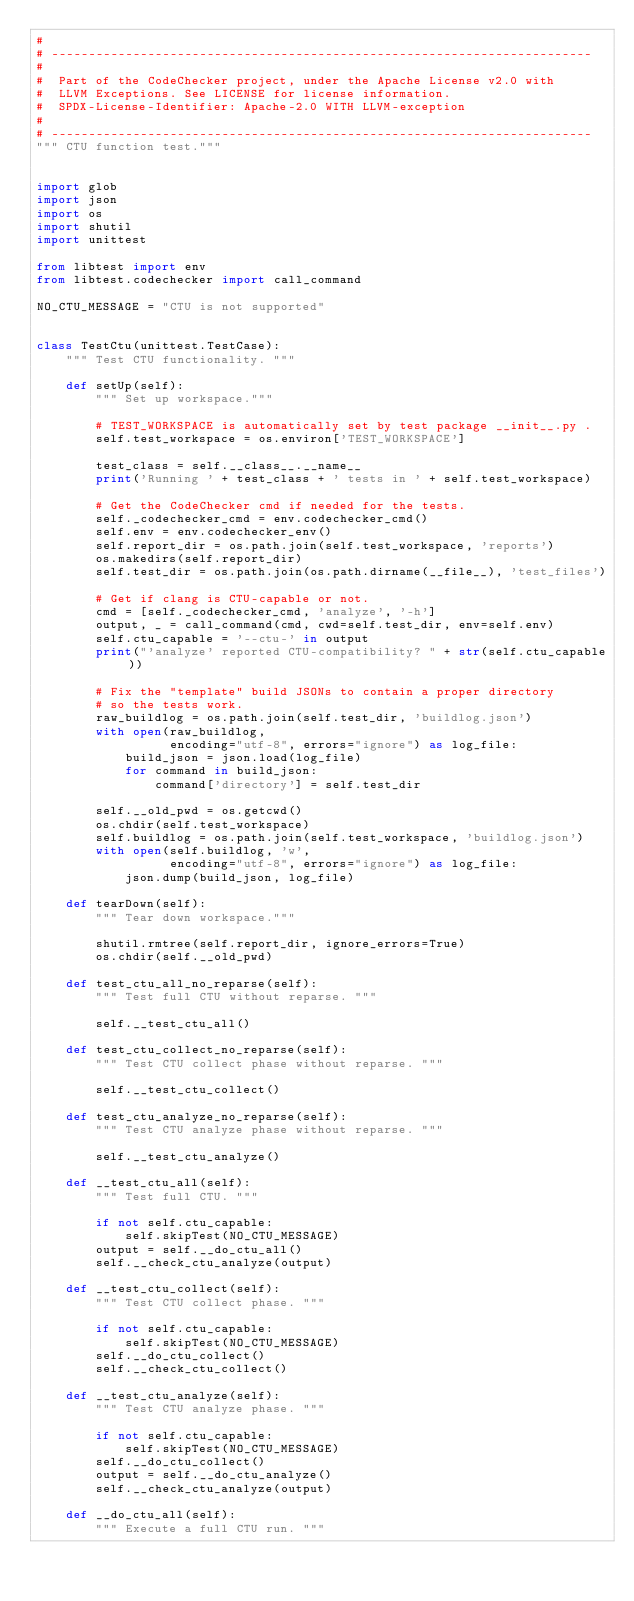Convert code to text. <code><loc_0><loc_0><loc_500><loc_500><_Python_>#
# -------------------------------------------------------------------------
#
#  Part of the CodeChecker project, under the Apache License v2.0 with
#  LLVM Exceptions. See LICENSE for license information.
#  SPDX-License-Identifier: Apache-2.0 WITH LLVM-exception
#
# -------------------------------------------------------------------------
""" CTU function test."""


import glob
import json
import os
import shutil
import unittest

from libtest import env
from libtest.codechecker import call_command

NO_CTU_MESSAGE = "CTU is not supported"


class TestCtu(unittest.TestCase):
    """ Test CTU functionality. """

    def setUp(self):
        """ Set up workspace."""

        # TEST_WORKSPACE is automatically set by test package __init__.py .
        self.test_workspace = os.environ['TEST_WORKSPACE']

        test_class = self.__class__.__name__
        print('Running ' + test_class + ' tests in ' + self.test_workspace)

        # Get the CodeChecker cmd if needed for the tests.
        self._codechecker_cmd = env.codechecker_cmd()
        self.env = env.codechecker_env()
        self.report_dir = os.path.join(self.test_workspace, 'reports')
        os.makedirs(self.report_dir)
        self.test_dir = os.path.join(os.path.dirname(__file__), 'test_files')

        # Get if clang is CTU-capable or not.
        cmd = [self._codechecker_cmd, 'analyze', '-h']
        output, _ = call_command(cmd, cwd=self.test_dir, env=self.env)
        self.ctu_capable = '--ctu-' in output
        print("'analyze' reported CTU-compatibility? " + str(self.ctu_capable))

        # Fix the "template" build JSONs to contain a proper directory
        # so the tests work.
        raw_buildlog = os.path.join(self.test_dir, 'buildlog.json')
        with open(raw_buildlog,
                  encoding="utf-8", errors="ignore") as log_file:
            build_json = json.load(log_file)
            for command in build_json:
                command['directory'] = self.test_dir

        self.__old_pwd = os.getcwd()
        os.chdir(self.test_workspace)
        self.buildlog = os.path.join(self.test_workspace, 'buildlog.json')
        with open(self.buildlog, 'w',
                  encoding="utf-8", errors="ignore") as log_file:
            json.dump(build_json, log_file)

    def tearDown(self):
        """ Tear down workspace."""

        shutil.rmtree(self.report_dir, ignore_errors=True)
        os.chdir(self.__old_pwd)

    def test_ctu_all_no_reparse(self):
        """ Test full CTU without reparse. """

        self.__test_ctu_all()

    def test_ctu_collect_no_reparse(self):
        """ Test CTU collect phase without reparse. """

        self.__test_ctu_collect()

    def test_ctu_analyze_no_reparse(self):
        """ Test CTU analyze phase without reparse. """

        self.__test_ctu_analyze()

    def __test_ctu_all(self):
        """ Test full CTU. """

        if not self.ctu_capable:
            self.skipTest(NO_CTU_MESSAGE)
        output = self.__do_ctu_all()
        self.__check_ctu_analyze(output)

    def __test_ctu_collect(self):
        """ Test CTU collect phase. """

        if not self.ctu_capable:
            self.skipTest(NO_CTU_MESSAGE)
        self.__do_ctu_collect()
        self.__check_ctu_collect()

    def __test_ctu_analyze(self):
        """ Test CTU analyze phase. """

        if not self.ctu_capable:
            self.skipTest(NO_CTU_MESSAGE)
        self.__do_ctu_collect()
        output = self.__do_ctu_analyze()
        self.__check_ctu_analyze(output)

    def __do_ctu_all(self):
        """ Execute a full CTU run. """
</code> 